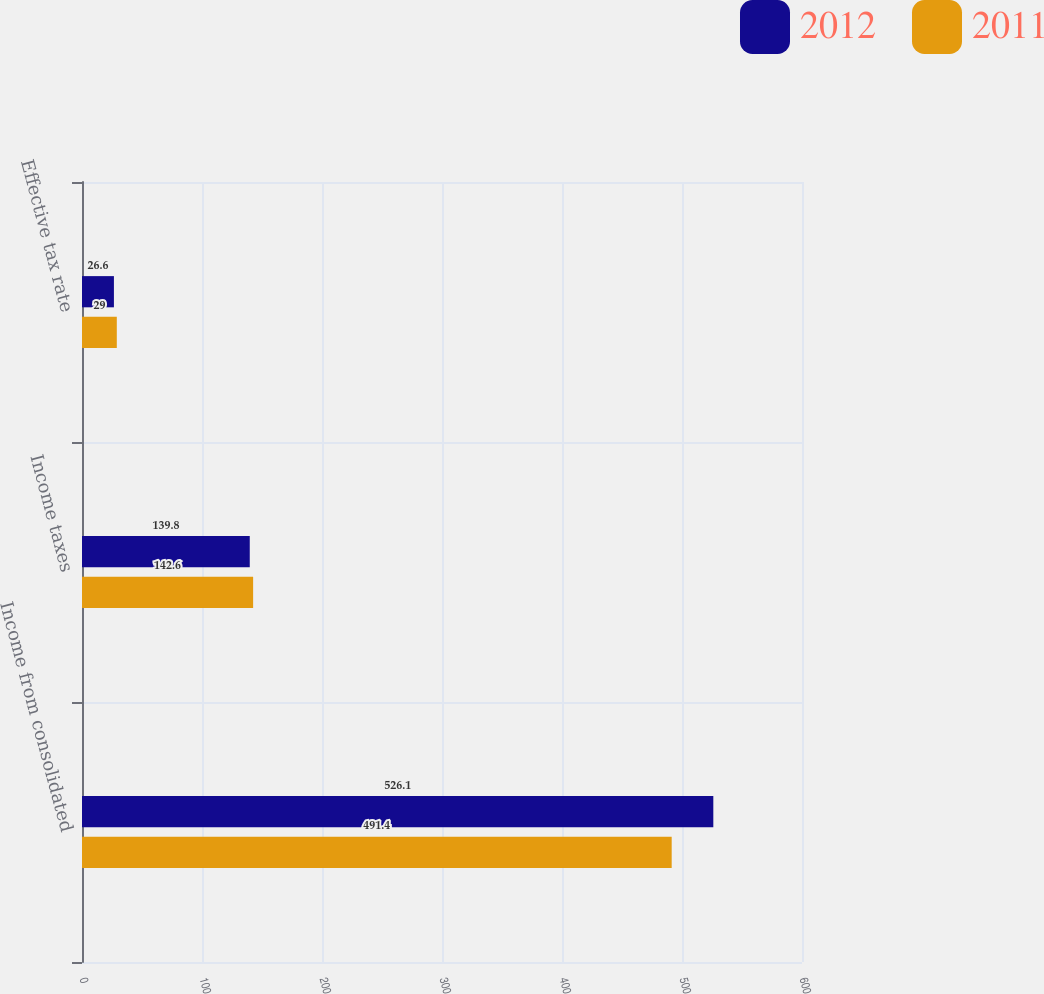Convert chart. <chart><loc_0><loc_0><loc_500><loc_500><stacked_bar_chart><ecel><fcel>Income from consolidated<fcel>Income taxes<fcel>Effective tax rate<nl><fcel>2012<fcel>526.1<fcel>139.8<fcel>26.6<nl><fcel>2011<fcel>491.4<fcel>142.6<fcel>29<nl></chart> 